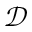<formula> <loc_0><loc_0><loc_500><loc_500>\mathcal { D }</formula> 